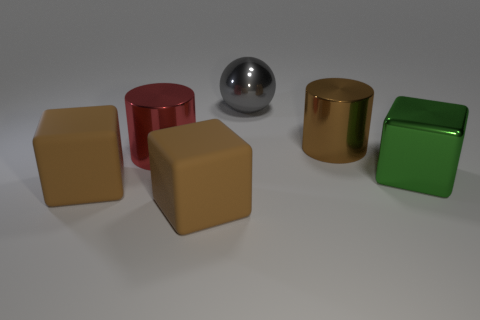Add 3 big blue cubes. How many objects exist? 9 Subtract all cylinders. How many objects are left? 4 Subtract 0 yellow blocks. How many objects are left? 6 Subtract all big red cylinders. Subtract all big brown blocks. How many objects are left? 3 Add 1 brown metal things. How many brown metal things are left? 2 Add 1 large brown rubber things. How many large brown rubber things exist? 3 